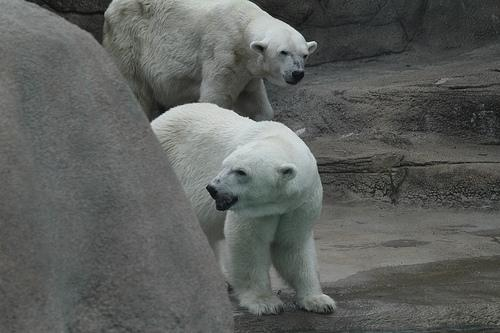Question: when was the picture taken?
Choices:
A. Midnight.
B. Christmas.
C. During daylight.
D. Easter.
Answer with the letter. Answer: C Question: who takes care of polar bears?
Choices:
A. Zoo keepers.
B. Mothers.
C. Handlers.
D. Workers.
Answer with the letter. Answer: A Question: where are they located?
Choices:
A. Zoo.
B. Wild.
C. In a zoo setting.
D. Park.
Answer with the letter. Answer: C Question: what are these animals?
Choices:
A. Dogs.
B. Monkeys.
C. Polar bears.
D. Cats.
Answer with the letter. Answer: C 